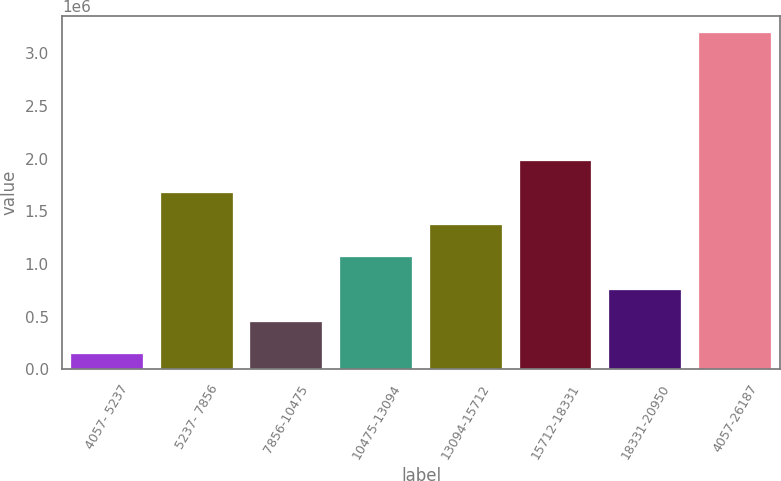Convert chart to OTSL. <chart><loc_0><loc_0><loc_500><loc_500><bar_chart><fcel>4057- 5237<fcel>5237- 7856<fcel>7856-10475<fcel>10475-13094<fcel>13094-15712<fcel>15712-18331<fcel>18331-20950<fcel>4057-26187<nl><fcel>147840<fcel>1.67185e+06<fcel>452642<fcel>1.06225e+06<fcel>1.36705e+06<fcel>1.97665e+06<fcel>757445<fcel>3.19586e+06<nl></chart> 